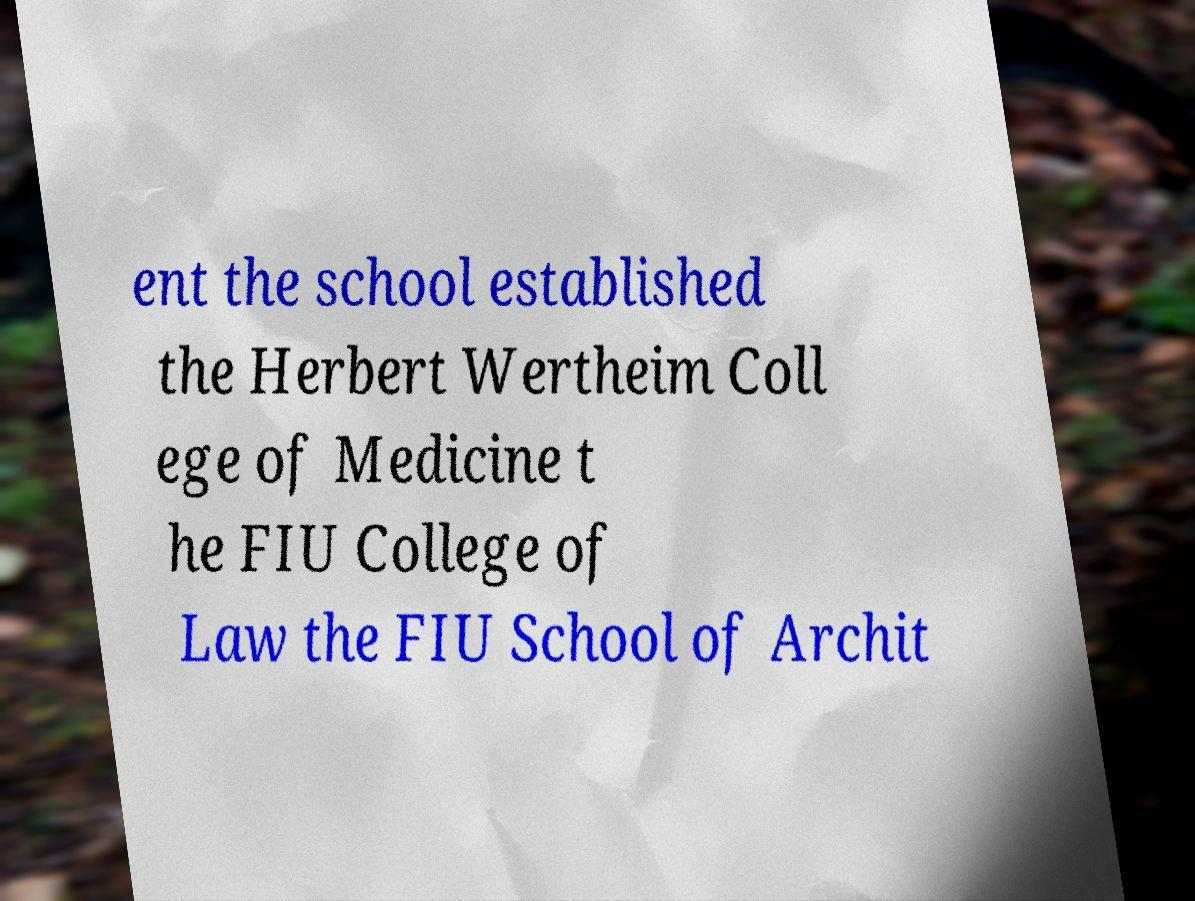Please read and relay the text visible in this image. What does it say? ent the school established the Herbert Wertheim Coll ege of Medicine t he FIU College of Law the FIU School of Archit 